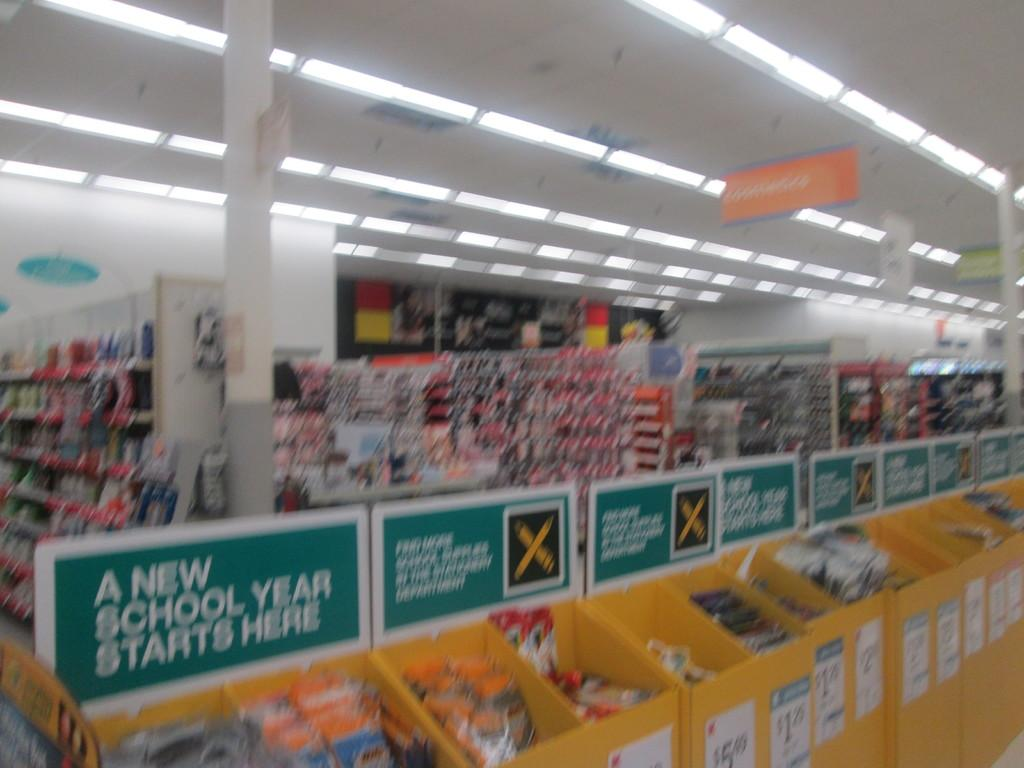<image>
Relay a brief, clear account of the picture shown. A store with bins full of school supplies and a sign stating "A New School Year Starts Here". 